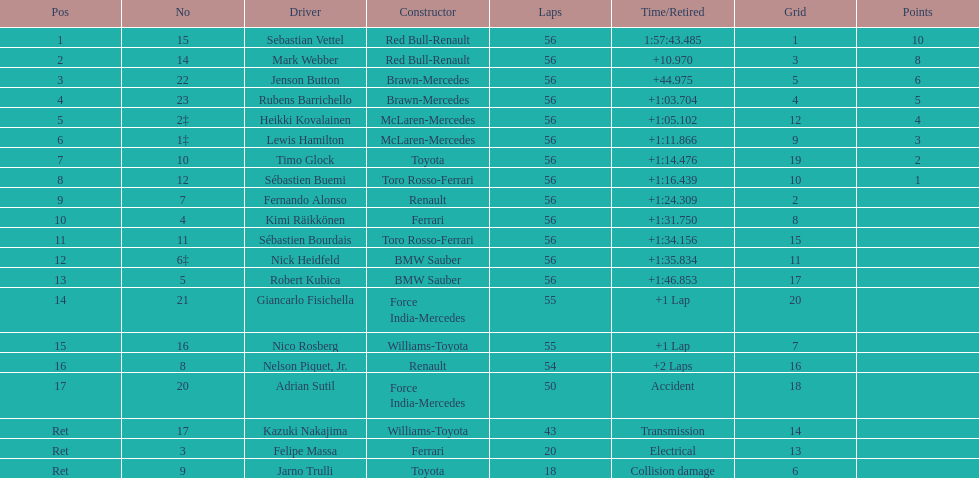Who was the slowest driver to finish the race? Robert Kubica. 